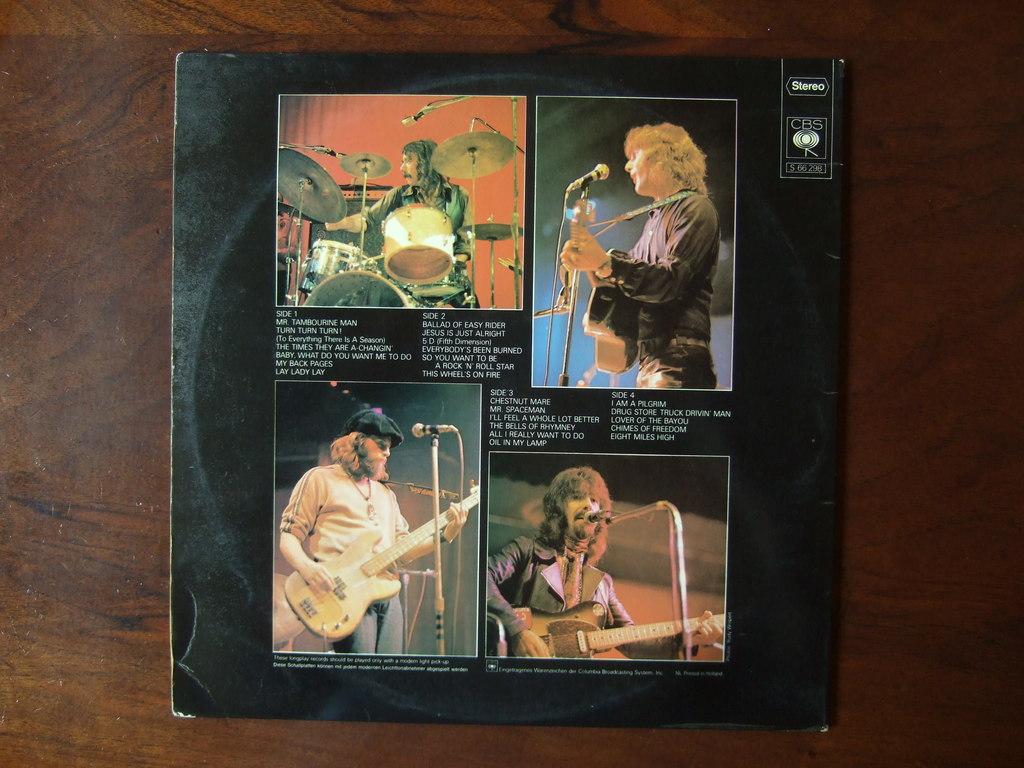How many sides are there mentioned on the back?
Provide a short and direct response. 4. 